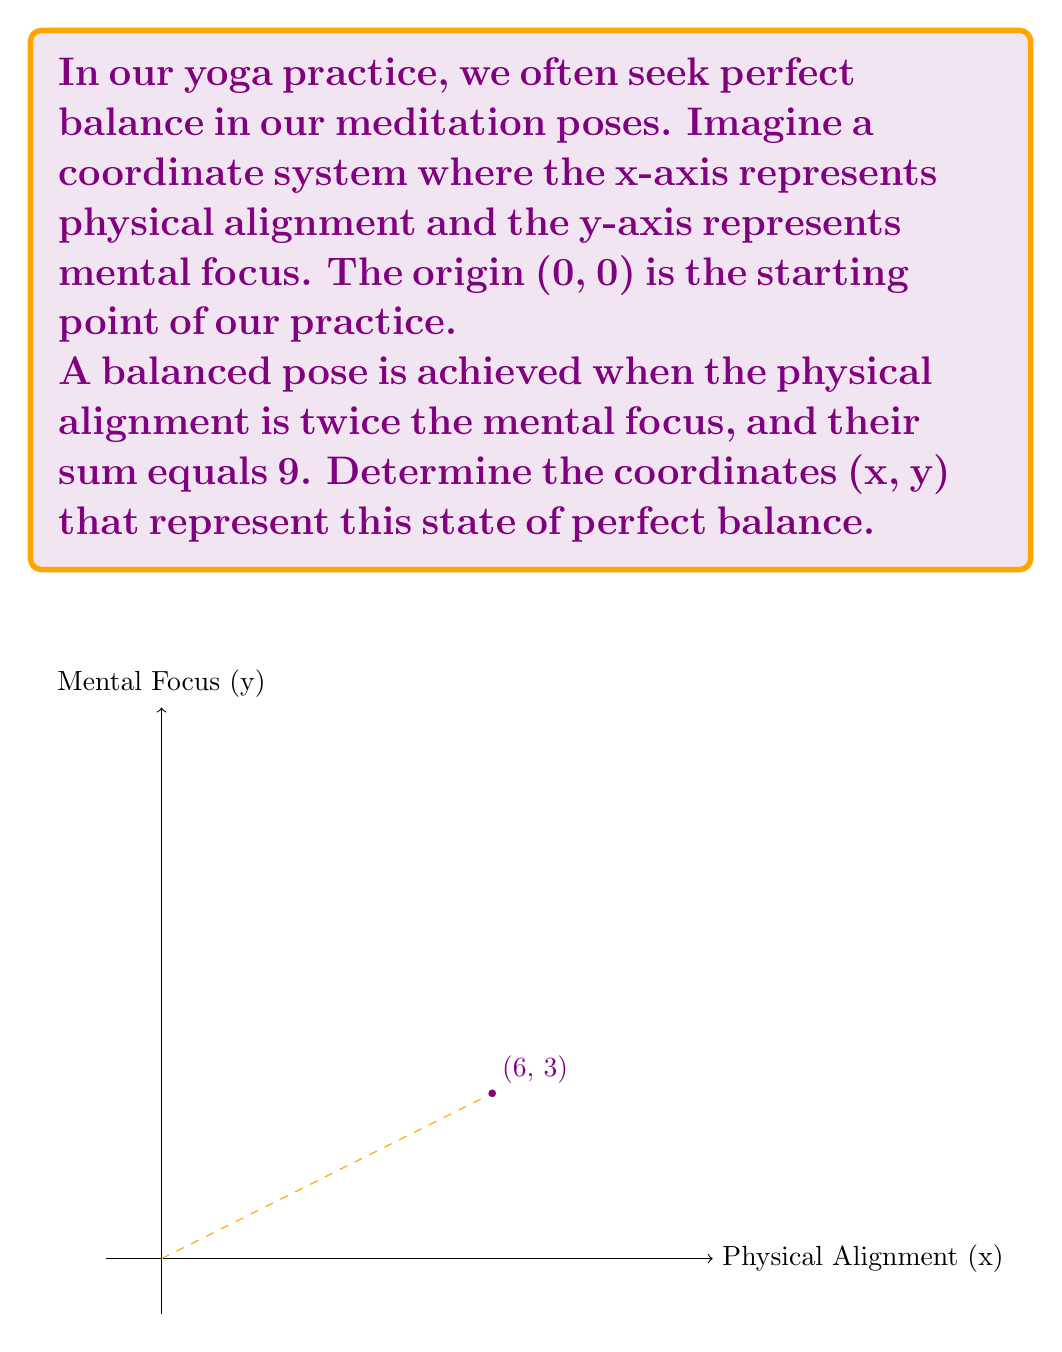Can you solve this math problem? Let's approach this step-by-step:

1) We're told that physical alignment (x) is twice the mental focus (y):
   $$x = 2y$$

2) We're also told that their sum equals 9:
   $$x + y = 9$$

3) Let's substitute the first equation into the second:
   $$(2y) + y = 9$$

4) Simplify:
   $$3y = 9$$

5) Solve for y:
   $$y = 3$$

6) Now that we know y, we can find x using the first equation:
   $$x = 2y = 2(3) = 6$$

7) Therefore, the coordinates of perfect balance are (6, 3).

To verify:
- Is x twice y? Yes, 6 is twice 3.
- Does x + y equal 9? Yes, 6 + 3 = 9.

This point (6, 3) represents the perfect balance where physical alignment is at 6 units and mental focus is at 3 units on our meditation coordinate system.
Answer: (6, 3) 